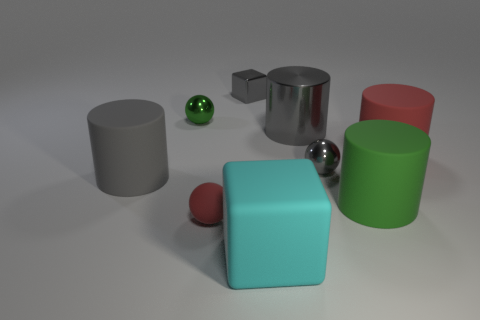Are there an equal number of large blocks in front of the large cyan matte thing and large cubes that are behind the small red matte object?
Your response must be concise. Yes. How many big matte objects have the same color as the tiny cube?
Make the answer very short. 1. What is the material of the block that is the same color as the metallic cylinder?
Provide a succinct answer. Metal. What number of shiny objects are large purple cylinders or small gray spheres?
Ensure brevity in your answer.  1. Does the large gray rubber thing in front of the big red rubber cylinder have the same shape as the green thing that is on the right side of the green metal ball?
Provide a succinct answer. Yes. How many red cylinders are behind the gray metallic block?
Offer a very short reply. 0. Is there a cube made of the same material as the red cylinder?
Provide a short and direct response. Yes. What material is the gray block that is the same size as the rubber sphere?
Your response must be concise. Metal. Are the green sphere and the gray block made of the same material?
Ensure brevity in your answer.  Yes. What number of objects are large shiny cylinders or big red cylinders?
Provide a succinct answer. 2. 